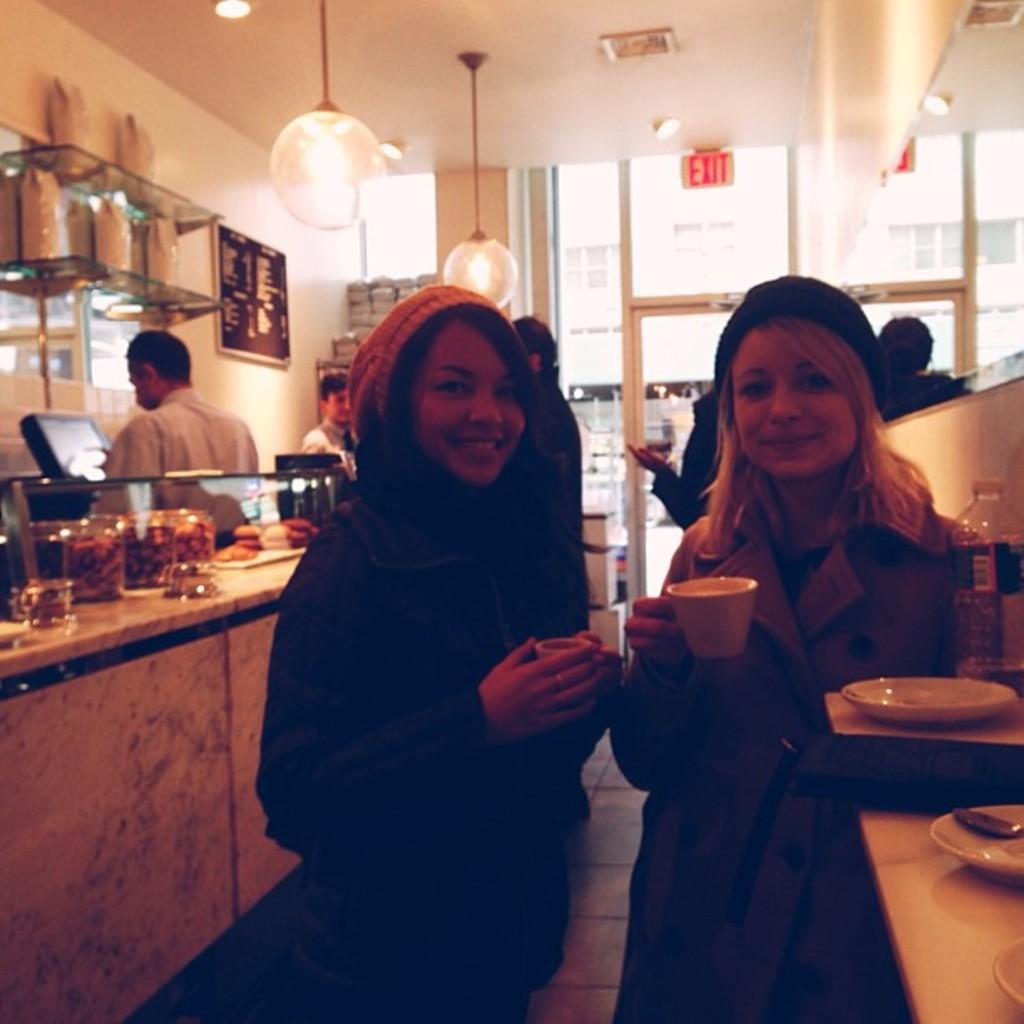How would you summarize this image in a sentence or two? In the picture there are two women standing in a cafe and posing for the photo, booth of them all holding cups with some drink and on the right side there are empty plates and behind the women there are some food items kept in the jars and behind the food items there are two people, in the background there is a wall and there is a menu card attached to the wall, on the right side there is an exit door. 